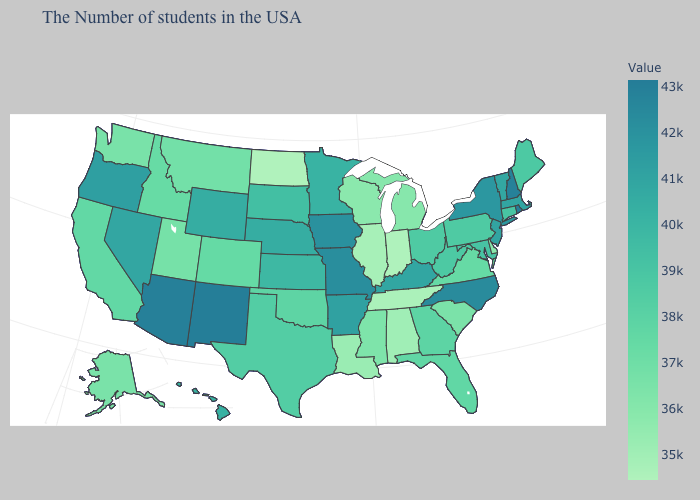Is the legend a continuous bar?
Answer briefly. Yes. Which states have the highest value in the USA?
Write a very short answer. Rhode Island. Among the states that border Kansas , which have the highest value?
Short answer required. Missouri. Is the legend a continuous bar?
Be succinct. Yes. Does Nebraska have the highest value in the USA?
Be succinct. No. Does Maryland have the highest value in the USA?
Quick response, please. No. Does Alaska have the lowest value in the West?
Keep it brief. Yes. 